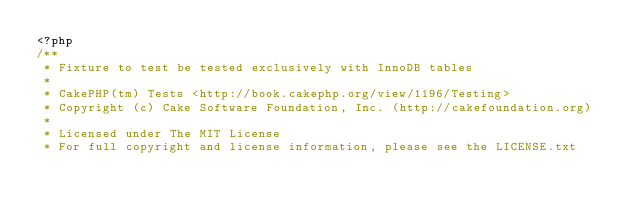Convert code to text. <code><loc_0><loc_0><loc_500><loc_500><_PHP_><?php
/**
 * Fixture to test be tested exclusively with InnoDB tables
 *
 * CakePHP(tm) Tests <http://book.cakephp.org/view/1196/Testing>
 * Copyright (c) Cake Software Foundation, Inc. (http://cakefoundation.org)
 *
 * Licensed under The MIT License
 * For full copyright and license information, please see the LICENSE.txt</code> 